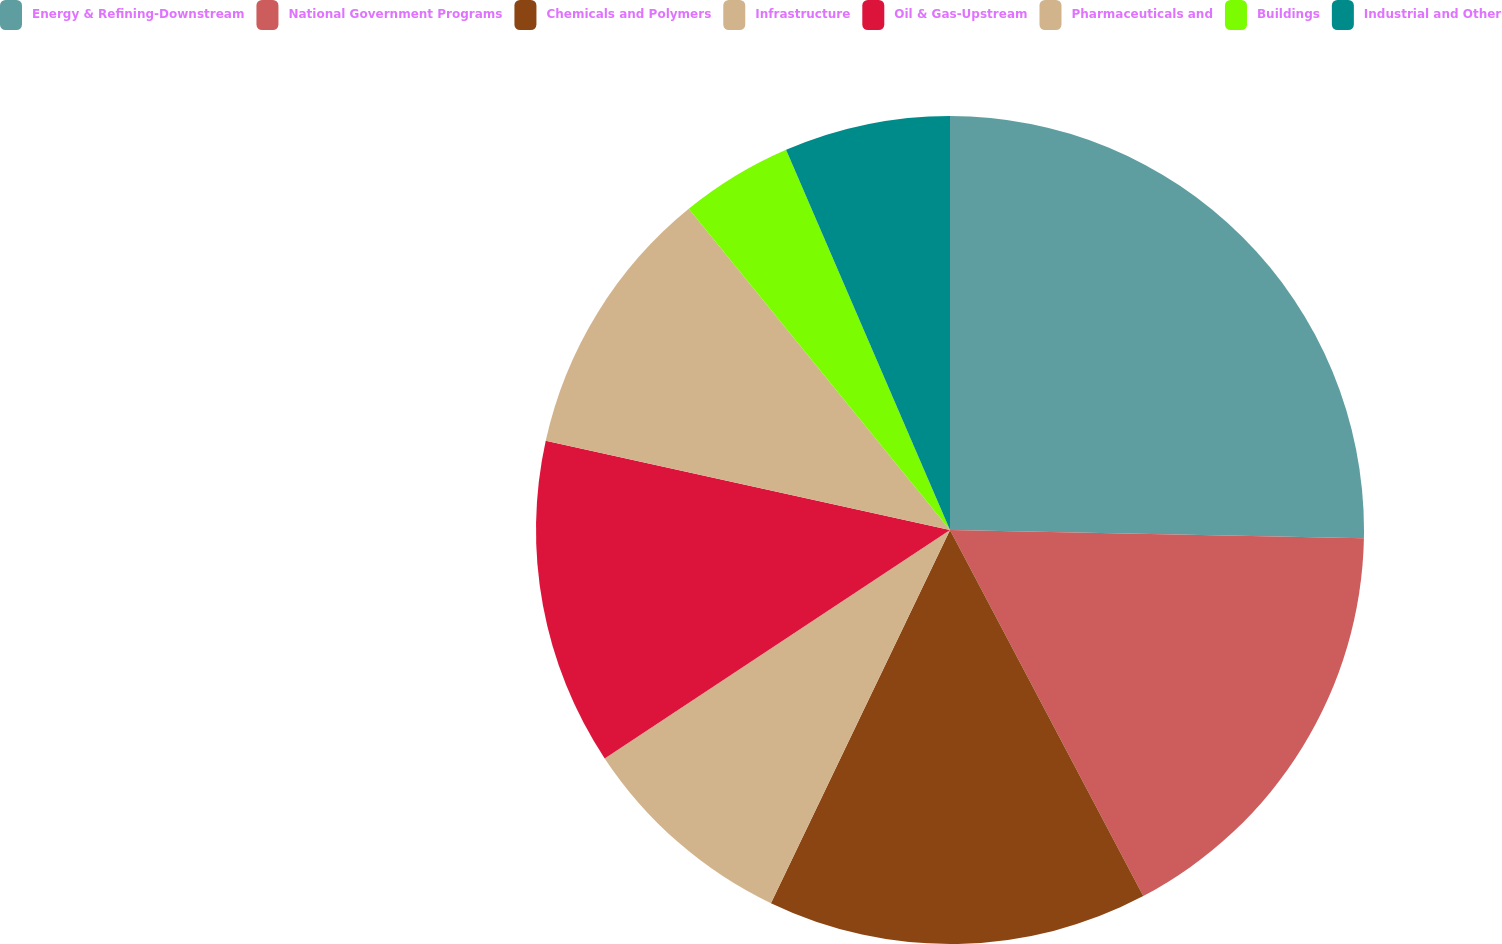Convert chart. <chart><loc_0><loc_0><loc_500><loc_500><pie_chart><fcel>Energy & Refining-Downstream<fcel>National Government Programs<fcel>Chemicals and Polymers<fcel>Infrastructure<fcel>Oil & Gas-Upstream<fcel>Pharmaceuticals and<fcel>Buildings<fcel>Industrial and Other<nl><fcel>25.32%<fcel>16.95%<fcel>14.85%<fcel>8.58%<fcel>12.76%<fcel>10.67%<fcel>4.39%<fcel>6.48%<nl></chart> 